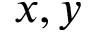<formula> <loc_0><loc_0><loc_500><loc_500>x , y</formula> 